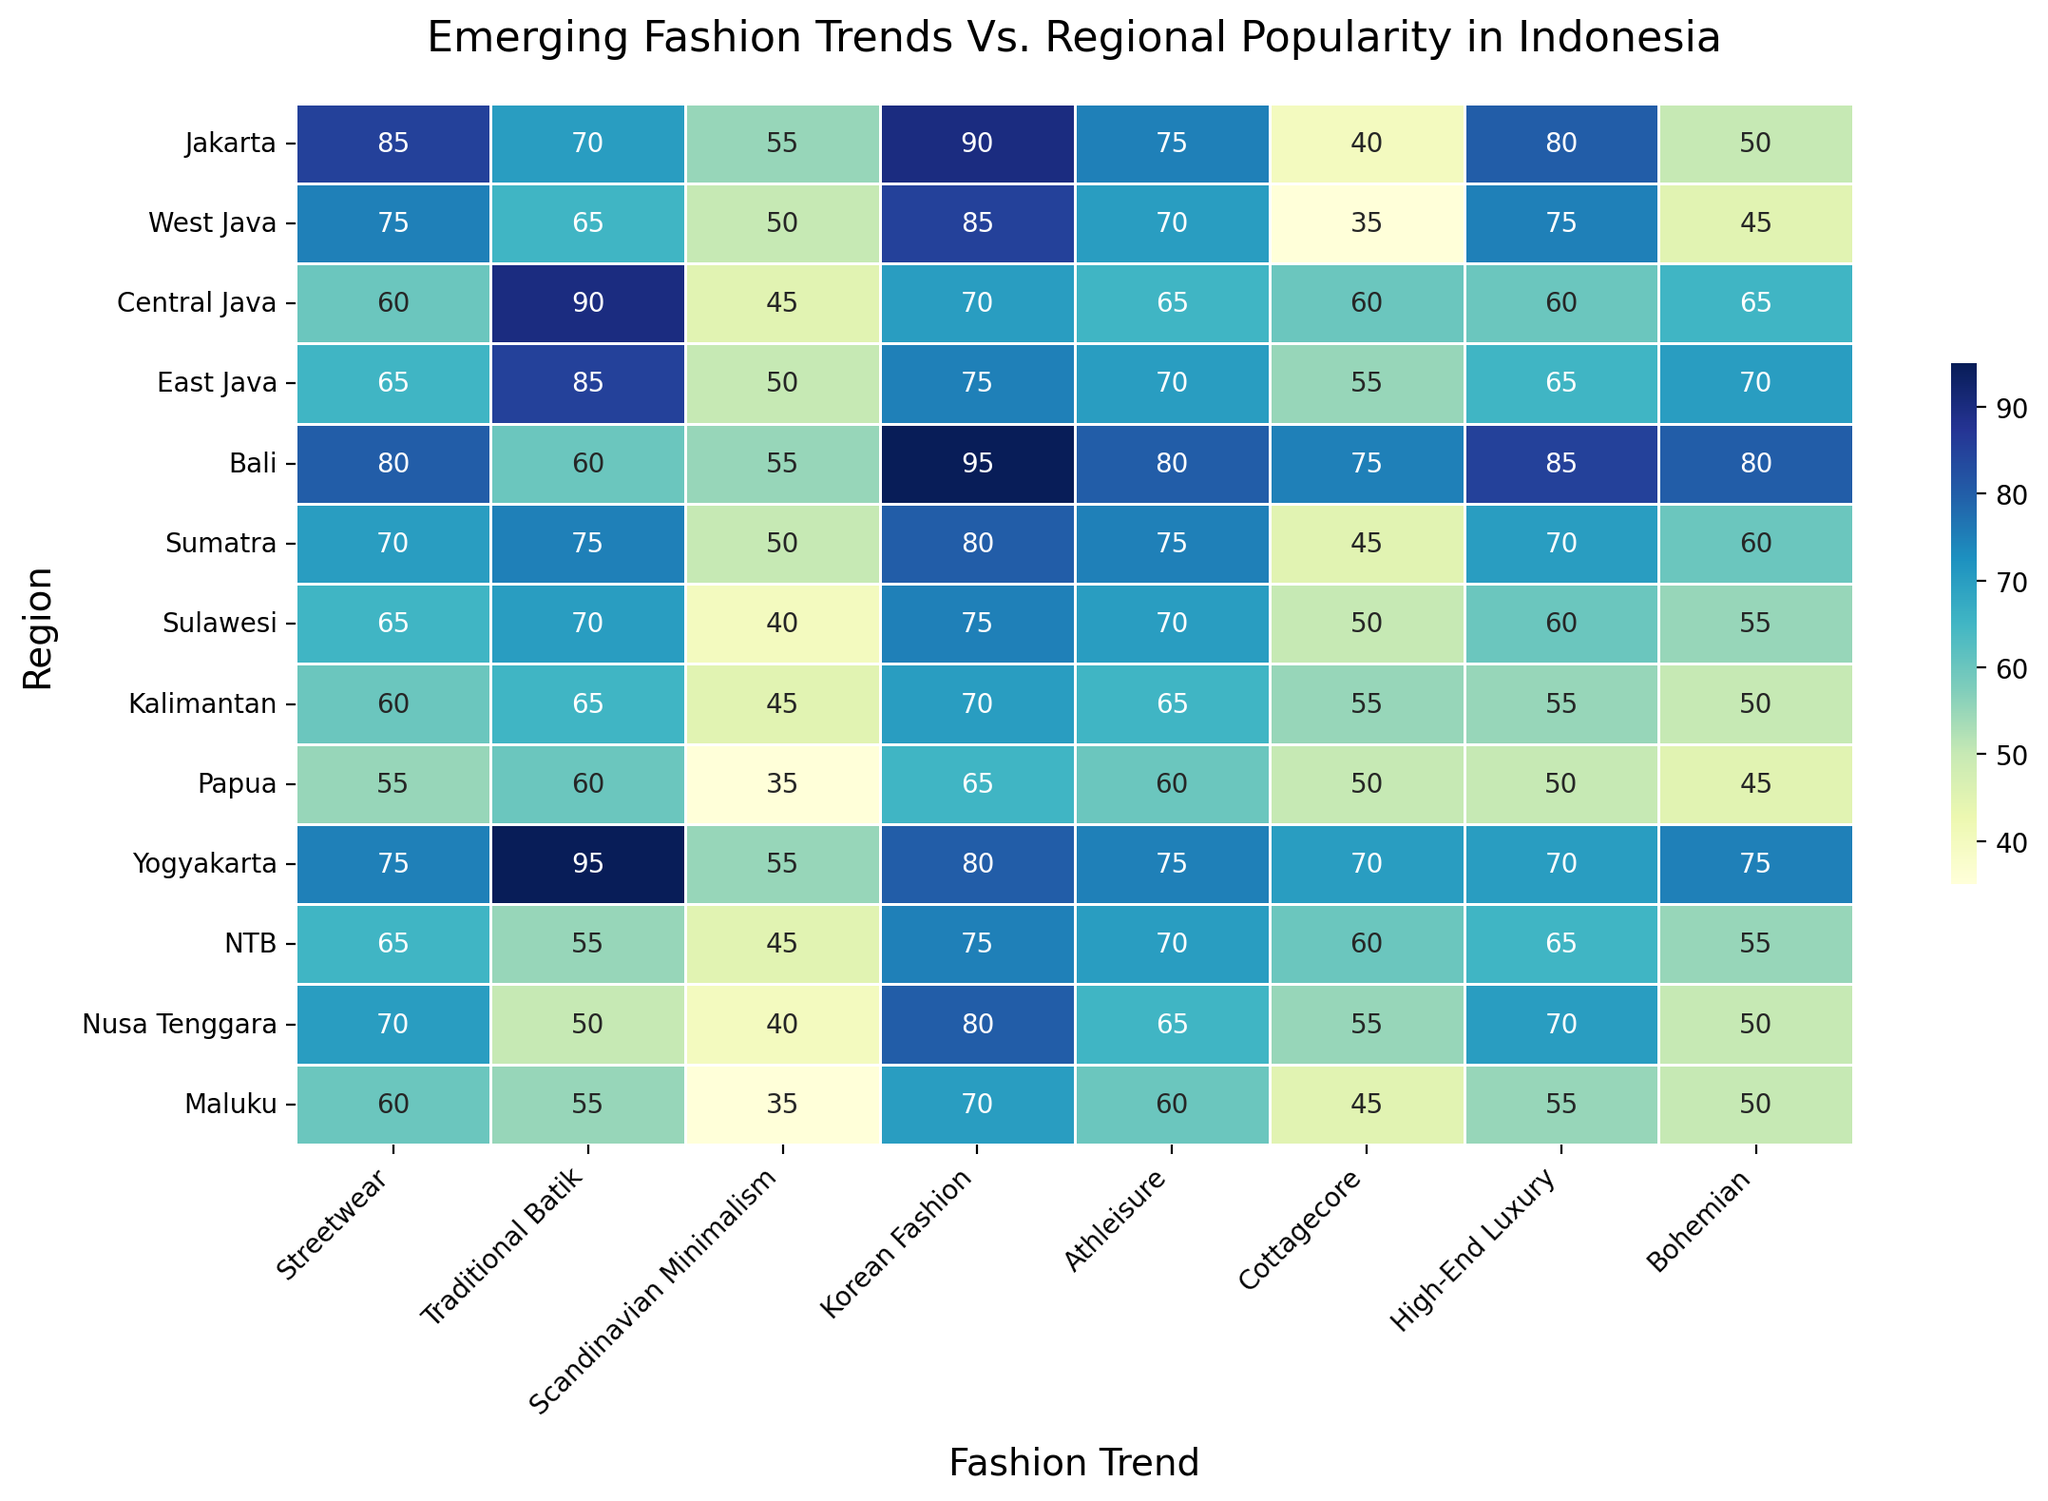Which region has the highest popularity for Korean Fashion? Look for the highest value under the "Korean Fashion" column. The highest value is 95, which corresponds to Bali.
Answer: Bali Compare the popularity of Traditional Batik in Central Java and East Java. Which region has a higher score? Find the values for Traditional Batik in both regions. Central Java has a score of 90, while East Java has a score of 85. Hence, Central Java has a higher score.
Answer: Central Java What is the average popularity score of High-End Luxury across all regions? Sum the High-End Luxury scores for all regions and divide by the number of regions (13). The total is 875, so the average is 875 / 13 ≈ 67.3.
Answer: 67.3 Identify the region with the lowest popularity for Cottagecore. Find the lowest value under the "Cottagecore" column. The lowest value is 40 in Jakarta.
Answer: Jakarta How many regions have a popularity score of 70 or higher for Streetwear? Count the values in the "Streetwear" column that are 70 or higher. There are six such regions: Jakarta, West Java, Bali, Sumatra, Yogyakarta, Nusa Tenggara.
Answer: 6 What is the difference in popularity for Bohemian fashion between Bali and Kalimantan? Subtract the value for Bohemian in Kalimantan (50) from the value in Bali (80). 80 - 50 = 30.
Answer: 30 Which fashion trend is most popular in Yogyakarta? Look for the highest value in the row for Yogyakarta. The highest value is 95 for Traditional Batik.
Answer: Traditional Batik Compare the total popularity scores of Athleisure in Jakarta and Sulawesi. Which region has a higher total score? Compare the individual scores for Athleisure in both regions. Jakarta has 75, and Sulawesi has 70. Therefore, Jakarta has a higher score.
Answer: Jakarta What is the sum of popularity scores for all fashion trends in Bali? Sum all the values for Bali across all fashion trends: 80 + 60 + 55 + 95 + 80 + 75 + 85 + 80 = 610.
Answer: 610 Which region has the lowest score for Scandinavian Minimalism, and what is that score? Find the lowest value under the "Scandinavian Minimalism" column. The lowest value is 35, which corresponds to Papua and Maluku.
Answer: Papua and Maluku, 35 